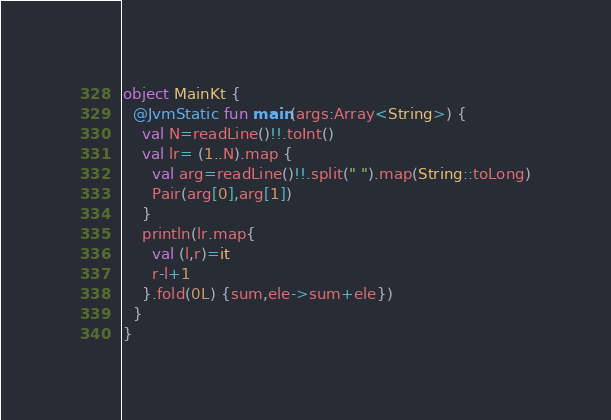<code> <loc_0><loc_0><loc_500><loc_500><_Kotlin_>object MainKt {
  @JvmStatic fun main(args:Array<String>) {
    val N=readLine()!!.toInt()
    val lr= (1..N).map {
      val arg=readLine()!!.split(" ").map(String::toLong)
      Pair(arg[0],arg[1])
    }
    println(lr.map{
      val (l,r)=it
      r-l+1
    }.fold(0L) {sum,ele->sum+ele})
  }
}</code> 